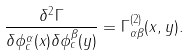<formula> <loc_0><loc_0><loc_500><loc_500>\frac { \delta ^ { 2 } \Gamma } { \delta \phi ^ { \alpha } _ { c } ( x ) \delta \phi ^ { \beta } _ { c } ( y ) } = \Gamma ^ { ( 2 ) } _ { \alpha \beta } ( x , y ) .</formula> 